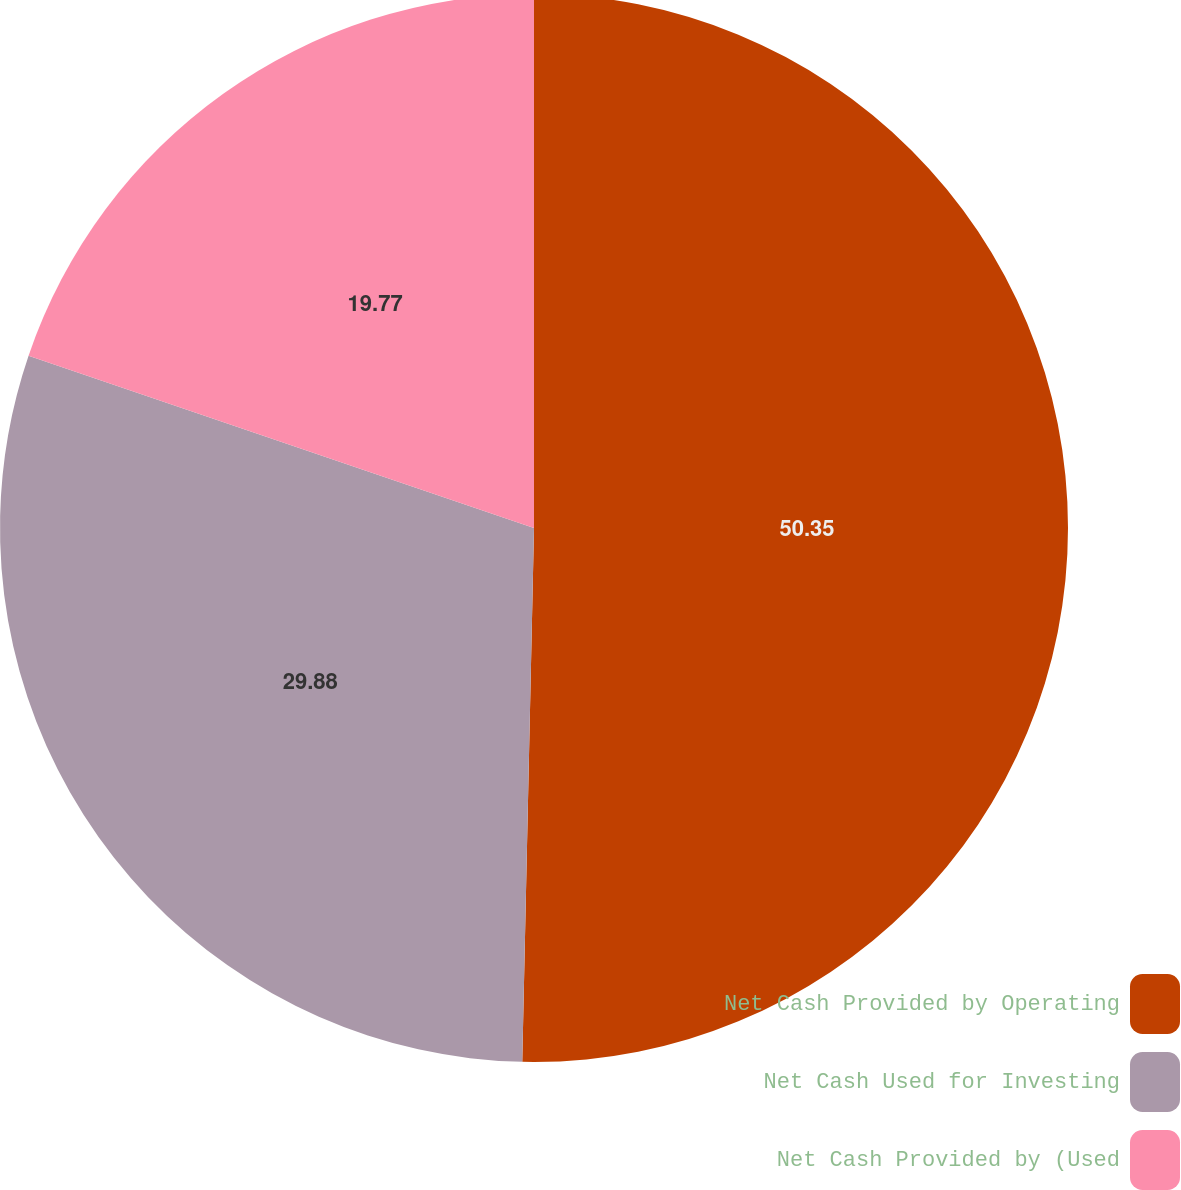Convert chart. <chart><loc_0><loc_0><loc_500><loc_500><pie_chart><fcel>Net Cash Provided by Operating<fcel>Net Cash Used for Investing<fcel>Net Cash Provided by (Used<nl><fcel>50.35%<fcel>29.88%<fcel>19.77%<nl></chart> 